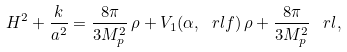Convert formula to latex. <formula><loc_0><loc_0><loc_500><loc_500>H ^ { 2 } + \frac { k } { a ^ { 2 } } = \frac { 8 \pi } { 3 M _ { p } ^ { 2 } } \, \rho + V _ { 1 } ( \alpha , \ r l f ) \, \rho + \frac { 8 \pi } { 3 M _ { p } ^ { 2 } } \, \ r l ,</formula> 